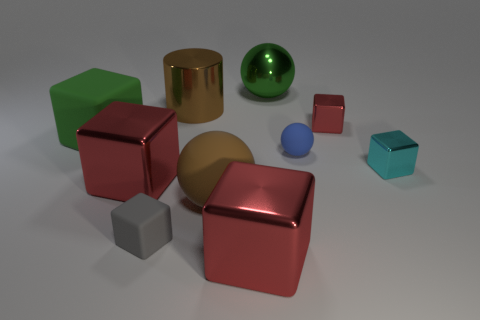Are there fewer red metallic cubes that are behind the blue rubber sphere than red things that are behind the big brown metal object?
Your response must be concise. No. What number of things are red blocks that are in front of the big brown ball or tiny blue matte balls?
Your response must be concise. 2. Does the green metallic ball have the same size as the ball that is on the right side of the metallic sphere?
Keep it short and to the point. No. What is the size of the gray matte object that is the same shape as the small cyan thing?
Keep it short and to the point. Small. What number of tiny red things are in front of the green thing that is on the left side of the large rubber thing in front of the large green matte block?
Your answer should be very brief. 0. What number of cylinders are brown metallic things or big brown things?
Your response must be concise. 1. There is a small metal object that is in front of the red object right of the big green object that is behind the green rubber cube; what color is it?
Give a very brief answer. Cyan. What number of other things are there of the same size as the brown matte thing?
Your answer should be very brief. 5. Is there any other thing that has the same shape as the brown metallic object?
Offer a very short reply. No. The other tiny metal object that is the same shape as the cyan object is what color?
Ensure brevity in your answer.  Red. 